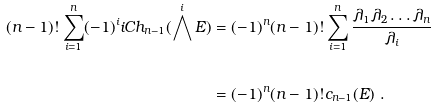Convert formula to latex. <formula><loc_0><loc_0><loc_500><loc_500>( n - 1 ) ! \sum _ { i = 1 } ^ { n } ( - 1 ) ^ { i } i C h _ { n - 1 } ( \bigwedge ^ { i } E ) & = ( - 1 ) ^ { n } ( n - 1 ) ! \sum _ { i = 1 } ^ { n } \frac { \lambda _ { 1 } \lambda _ { 2 } \dots \lambda _ { n } } { \lambda _ { i } } \\ \ \\ & = ( - 1 ) ^ { n } ( n - 1 ) ! c _ { n - 1 } ( E ) \ .</formula> 